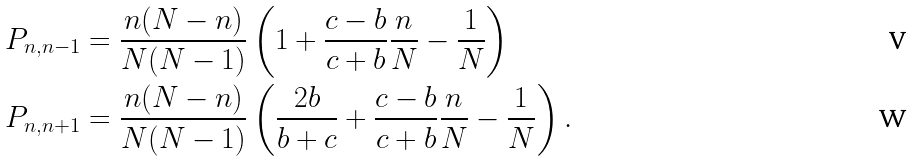Convert formula to latex. <formula><loc_0><loc_0><loc_500><loc_500>P _ { n , n - 1 } & = \frac { n ( N - n ) } { N ( N - 1 ) } \left ( 1 + \frac { c - b } { c + b } \frac { n } { N } - \frac { 1 } { N } \right ) \\ P _ { n , n + 1 } & = \frac { n ( N - n ) } { N ( N - 1 ) } \left ( \frac { 2 b } { b + c } + \frac { c - b } { c + b } \frac { n } { N } - \frac { 1 } { N } \right ) .</formula> 